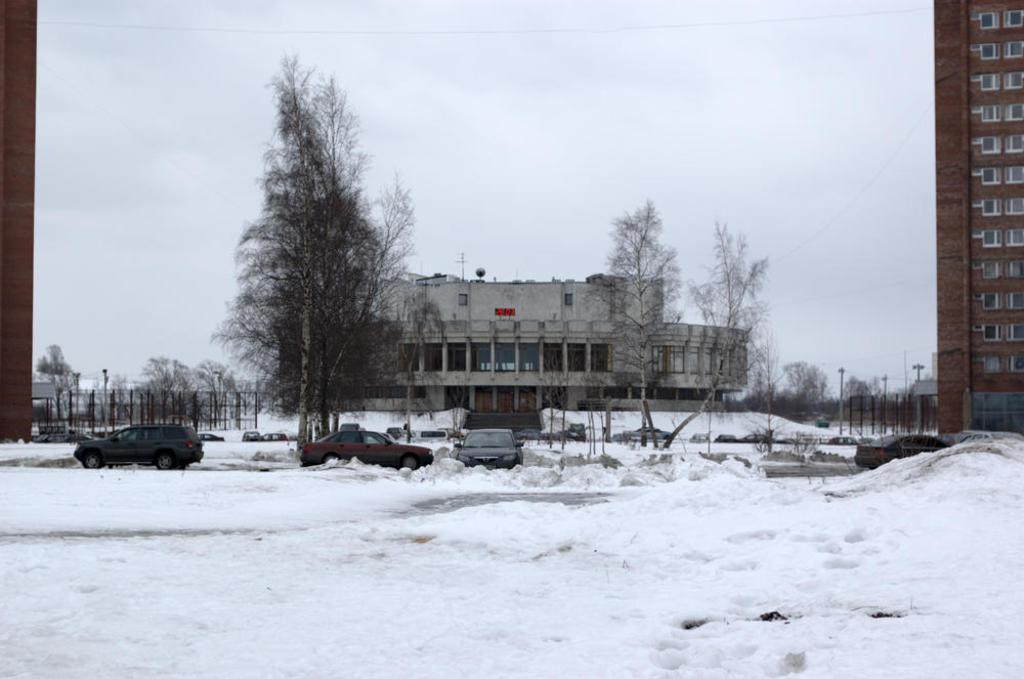What is the main subject of the image? The main subject of the image is vehicles in the snow. What can be seen in the background of the image? There are trees, buildings, and poles in the background of the image. What advice does the coach give to the dad in the image? There is no coach or dad present in the image; it only features vehicles in the snow and background elements. 